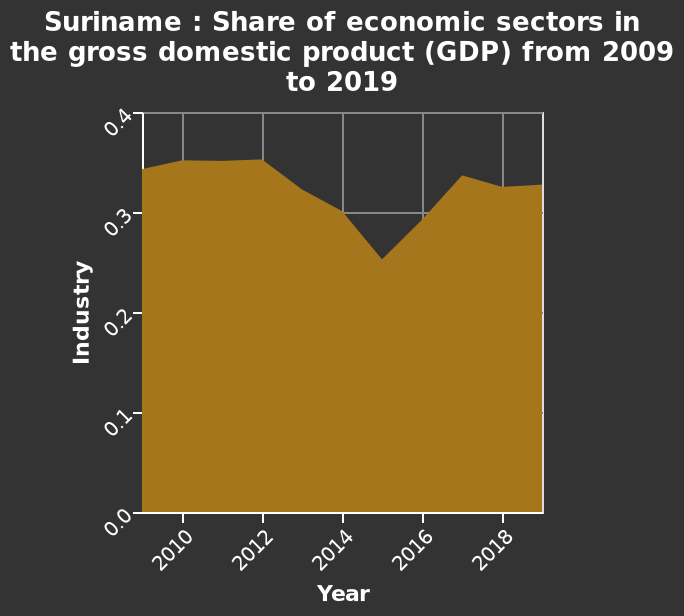<image>
What does the area graph named Suriname represent?  The area graph represents the share of economic sectors in the gross domestic product (GDP) in Suriname from 2009 to 2019. What does the y-axis measure in the area graph?  The y-axis measures the share of the Industry sector in the gross domestic product (GDP) on a linear scale from 0.0 to 0.4. please describe the details of the chart Here a is a area graph named Suriname : Share of economic sectors in the gross domestic product (GDP) from 2009 to 2019. The y-axis measures Industry as a linear scale from 0.0 to 0.4. The x-axis plots Year. What is the range of values represented on the y-axis?  The range of values on the y-axis is from 0.0 to 0.4, measured on a linear scale. How would you describe the share trend between 2010 and 2020? The share remains relatively stable between 0.3 and 0.4, except for a drop to around 0.25 in 2015, indicating a generally consistent trend over the years. In which year does the share drop to around 0.25?  The share drops to around 0.25 in the year 2015. What is the subject of analysis in the area graph? The area graph analyzes the changes in the share of economic sectors, particularly the Industry sector, in Suriname's gross domestic product (GDP) over the period from 2009 to 2019. Does the area graph analyze the changes in the share of economic sectors, particularly the Agriculture sector, in Suriname's gross domestic product (GDP) over the period from 2009 to 2019? No.The area graph analyzes the changes in the share of economic sectors, particularly the Industry sector, in Suriname's gross domestic product (GDP) over the period from 2009 to 2019. 